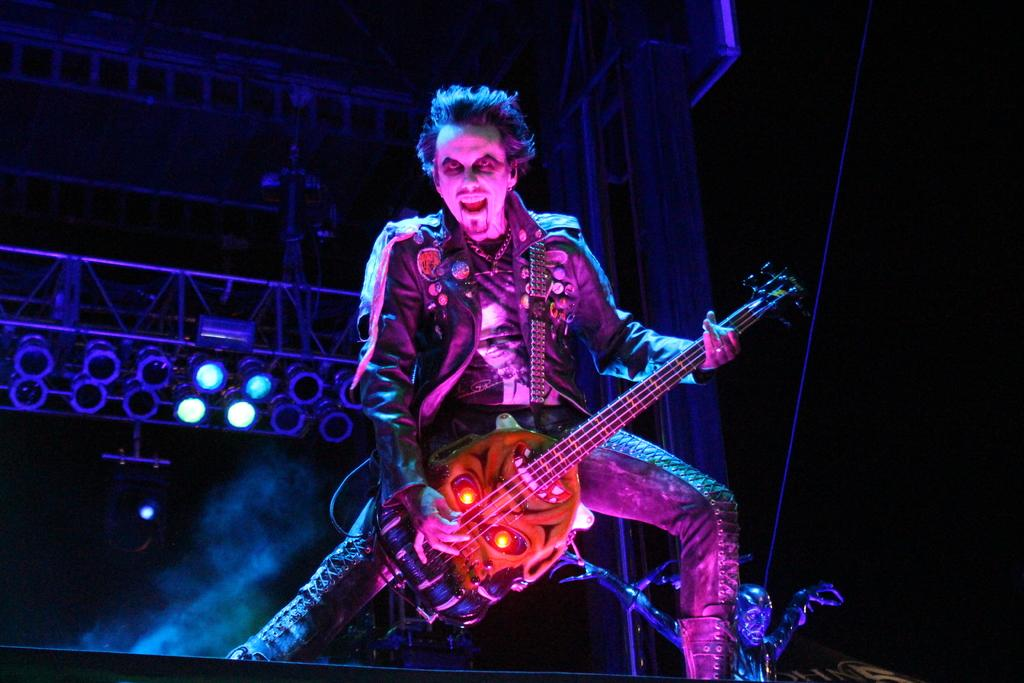What is the person in the image holding? The person in the image is holding a guitar. Can you describe the person in the image? There is a depiction of a person in the image. What can be seen in the background of the image? There are lights and metal rods in the background of the image. What type of pie is being served on the table in the image? There is no table or pie present in the image; it features a person holding a guitar and a background with lights and metal rods. 